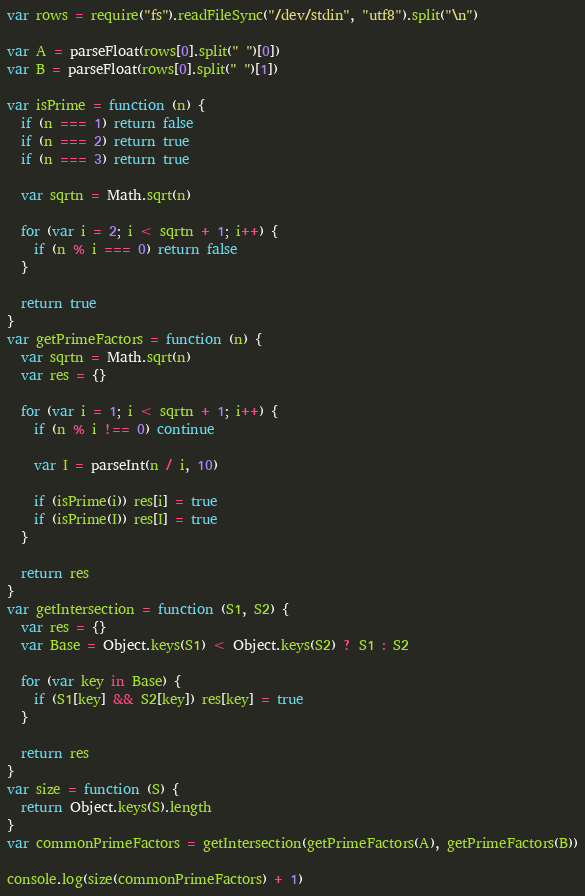<code> <loc_0><loc_0><loc_500><loc_500><_JavaScript_>var rows = require("fs").readFileSync("/dev/stdin", "utf8").split("\n")

var A = parseFloat(rows[0].split(" ")[0])
var B = parseFloat(rows[0].split(" ")[1])

var isPrime = function (n) {
  if (n === 1) return false
  if (n === 2) return true
  if (n === 3) return true

  var sqrtn = Math.sqrt(n)

  for (var i = 2; i < sqrtn + 1; i++) {
    if (n % i === 0) return false
  }

  return true
}
var getPrimeFactors = function (n) {
  var sqrtn = Math.sqrt(n)
  var res = {}

  for (var i = 1; i < sqrtn + 1; i++) {
    if (n % i !== 0) continue

    var I = parseInt(n / i, 10)

    if (isPrime(i)) res[i] = true
    if (isPrime(I)) res[I] = true
  }

  return res
}
var getIntersection = function (S1, S2) {
  var res = {}
  var Base = Object.keys(S1) < Object.keys(S2) ? S1 : S2

  for (var key in Base) {
    if (S1[key] && S2[key]) res[key] = true
  }

  return res
}
var size = function (S) {
  return Object.keys(S).length
}
var commonPrimeFactors = getIntersection(getPrimeFactors(A), getPrimeFactors(B))

console.log(size(commonPrimeFactors) + 1)
</code> 